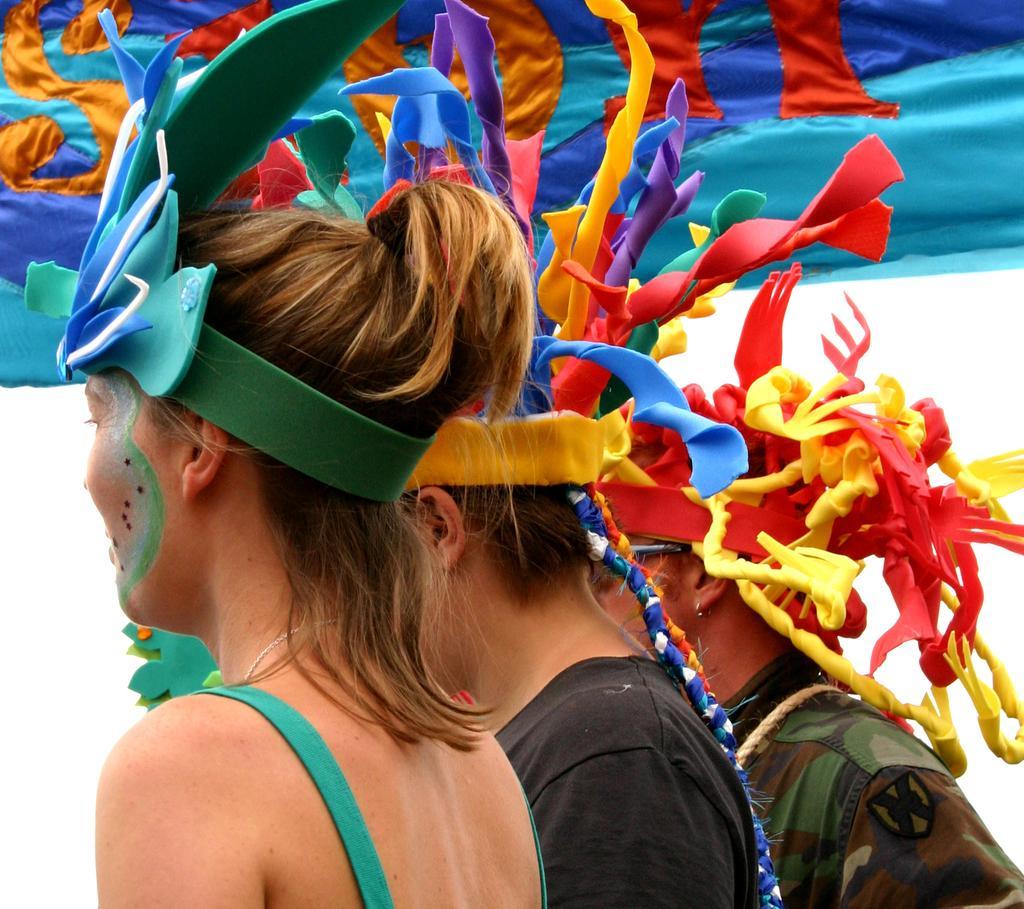In one or two sentences, can you explain what this image depicts? In this image there are three persons who are standing and they are wearing some costumes, in the background there is one cloth. 